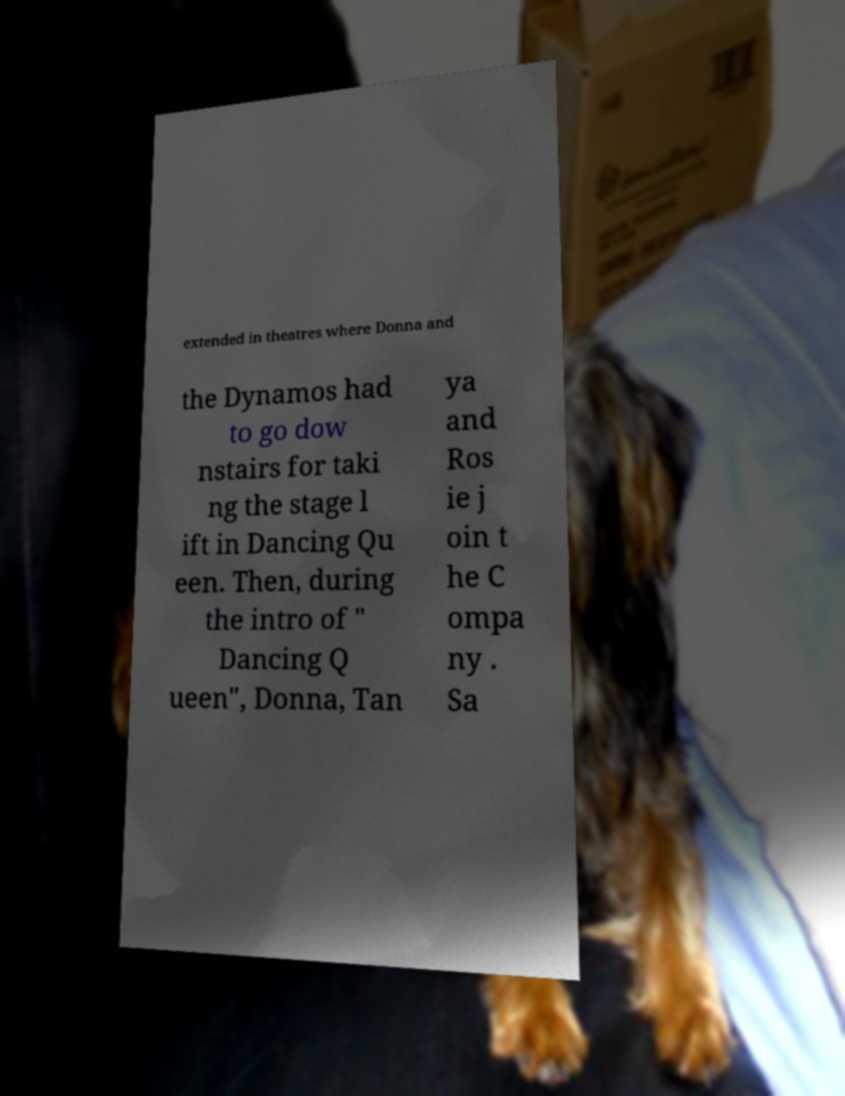What messages or text are displayed in this image? I need them in a readable, typed format. extended in theatres where Donna and the Dynamos had to go dow nstairs for taki ng the stage l ift in Dancing Qu een. Then, during the intro of " Dancing Q ueen", Donna, Tan ya and Ros ie j oin t he C ompa ny . Sa 